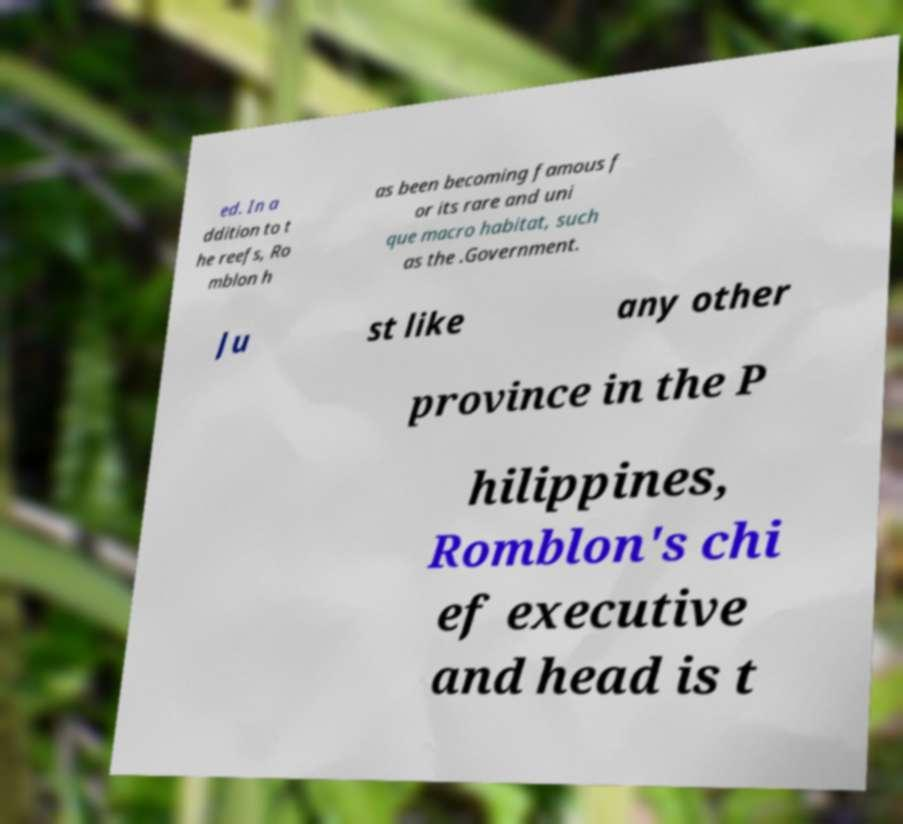For documentation purposes, I need the text within this image transcribed. Could you provide that? ed. In a ddition to t he reefs, Ro mblon h as been becoming famous f or its rare and uni que macro habitat, such as the .Government. Ju st like any other province in the P hilippines, Romblon's chi ef executive and head is t 